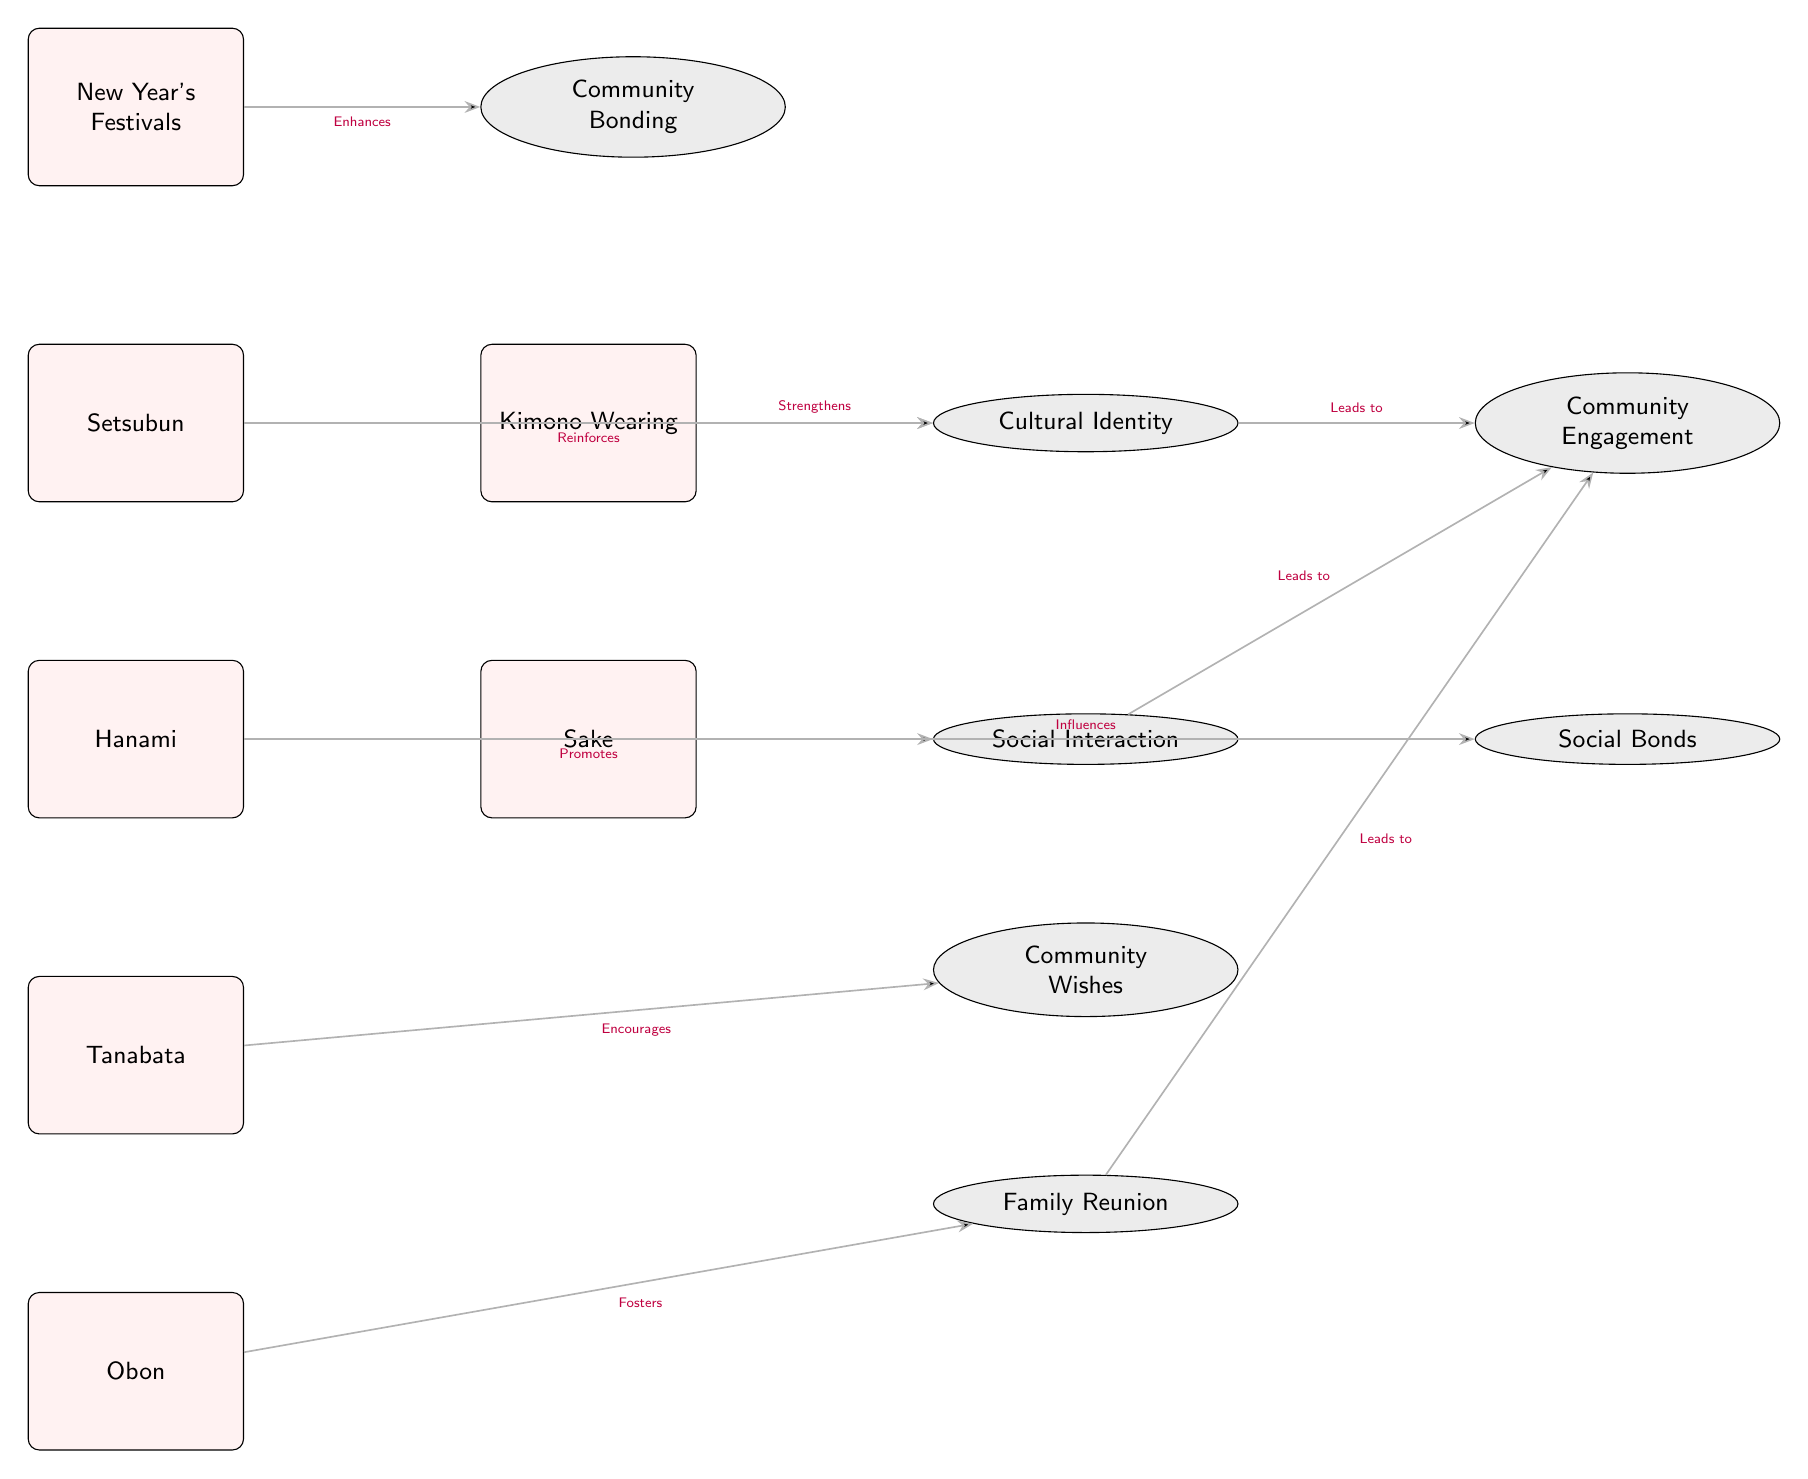What seasonal cultural event is at the top of the diagram? The diagram begins with "New Year's Festivals" at the top, indicating that it is the first event listed.
Answer: New Year's Festivals How many events are listed in the diagram? There are six events listed, counted from New Year's Festivals to Obon.
Answer: 6 What outcome is influenced by the event "Sake"? The diagram shows that "Sake" influences "Social Bonds," as indicated by the edge connecting these two nodes.
Answer: Social Bonds What action is associated with "Hanami"? The diagram states that "Hanami" promotes "Social Interaction," showing the relationship between the event and the outcome it encourages.
Answer: Promotes Which event is said to foster "Family Reunion"? "Obon" is connected to "Family Reunion" with the edge stating it fosters this outcome, highlighting the event's significance in family gatherings.
Answer: Obon What connection exists between "Cultural Identity" and "Community Engagement"? The diagram shows two edges leading from "Cultural Identity" to "Community Engagement," indicating that cultural identity is a pathway to stronger community involvement.
Answer: Leads to How many outcomes are connected to the event "Setsubun"? "Setsubun" is connected only to "Cultural Identity," indicating it directly reinforces this specific outcome.
Answer: 1 Which event encourages "Community Wishes"? The edge in the diagram indicates that "Tanabata" encourages "Community Wishes," establishing a direct correlation between the two.
Answer: Tanabata What is the last event listed in the diagram? At the bottom of the diagram, "Obon" is listed as the final event, concluding the sequence.
Answer: Obon 